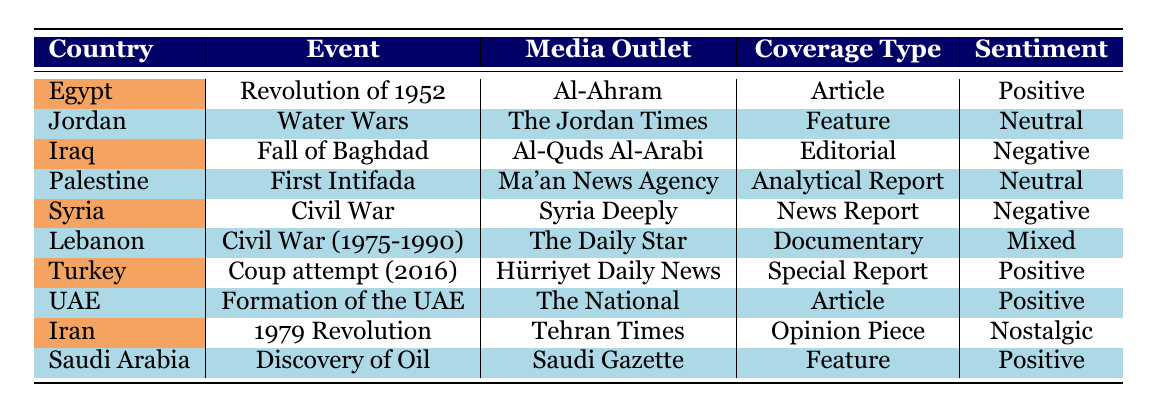What media outlet covered the "Fall of Baghdad"? The table lists the "Fall of Baghdad" event under the country Iraq, and it indicates that the media outlet is "Al-Quds Al-Arabi."
Answer: Al-Quds Al-Arabi Which event received a positive sentiment in 2023? Examining the table, the events listed for coverage in 2023 are the "Revolution of 1952" and the "Coup attempt (2016)." The "Revolution of 1952" has a positive sentiment according to the table.
Answer: Revolution of 1952 How many events had a neutral sentiment? From the table, the events that had a neutral sentiment are the "Water Wars" and the "First Intifada," totaling two events.
Answer: 2 Did "The Daily Star" provide coverage on the "Civil War (1975-1990)"? The table shows that "The Daily Star" did cover the "Civil War (1975-1990)," and it notes that the sentiment is mixed.
Answer: Yes Which country had events covered by outlets with different sentiments in 2022? In 2022, "Jordan" covered the "Water Wars" with a neutral sentiment, and "Lebanon" had the "Civil War (1975-1990)" with a mixed sentiment. Therefore, both events illustrate different sentiments in their coverage.
Answer: Jordan and Lebanon What is the coverage type of the event "Formation of the UAE"? According to the table, the "Formation of the UAE" event was covered by "The National" and the coverage type is an article.
Answer: Article Which event had editorial coverage and what was its sentiment? The event "Fall of Baghdad" had editorial coverage as noted in the table, and the sentiment associated with it is negative.
Answer: Fall of Baghdad, Negative How many different media outlets covered events in the table? By counting each unique media outlet mentioned, we find that there are 8 distinct outlets: Al-Ahram, The Jordan Times, Al-Quds Al-Arabi, Ma'an News Agency, Syria Deeply, The Daily Star, Hürriyet Daily News, The National, and Tehran Times. Therefore, the total number is 8.
Answer: 8 Was there any event related to Iran that had nostalgic sentiment? Yes, the table indicates that the event "1979 Revolution" is associated with "Tehran Times," and the sentiment is nostalgic.
Answer: Yes 